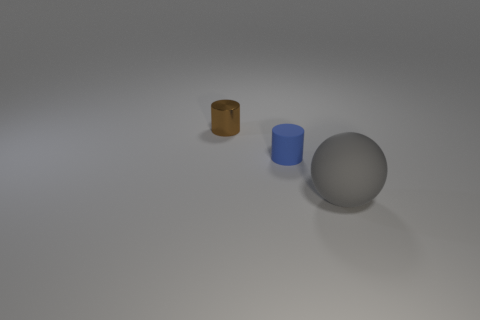Add 2 big brown cylinders. How many objects exist? 5 Subtract all spheres. How many objects are left? 2 Add 2 tiny brown cylinders. How many tiny brown cylinders are left? 3 Add 3 small gray metal things. How many small gray metal things exist? 3 Subtract 0 green blocks. How many objects are left? 3 Subtract all brown metal things. Subtract all gray matte objects. How many objects are left? 1 